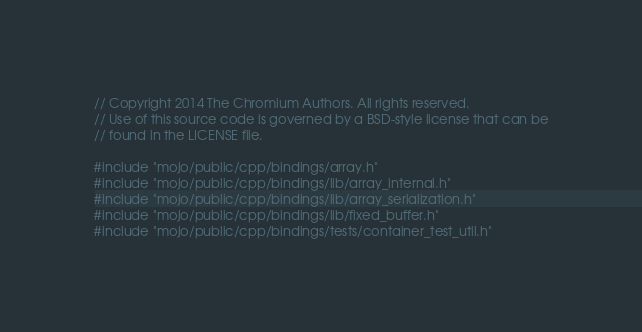<code> <loc_0><loc_0><loc_500><loc_500><_C++_>// Copyright 2014 The Chromium Authors. All rights reserved.
// Use of this source code is governed by a BSD-style license that can be
// found in the LICENSE file.

#include "mojo/public/cpp/bindings/array.h"
#include "mojo/public/cpp/bindings/lib/array_internal.h"
#include "mojo/public/cpp/bindings/lib/array_serialization.h"
#include "mojo/public/cpp/bindings/lib/fixed_buffer.h"
#include "mojo/public/cpp/bindings/tests/container_test_util.h"</code> 